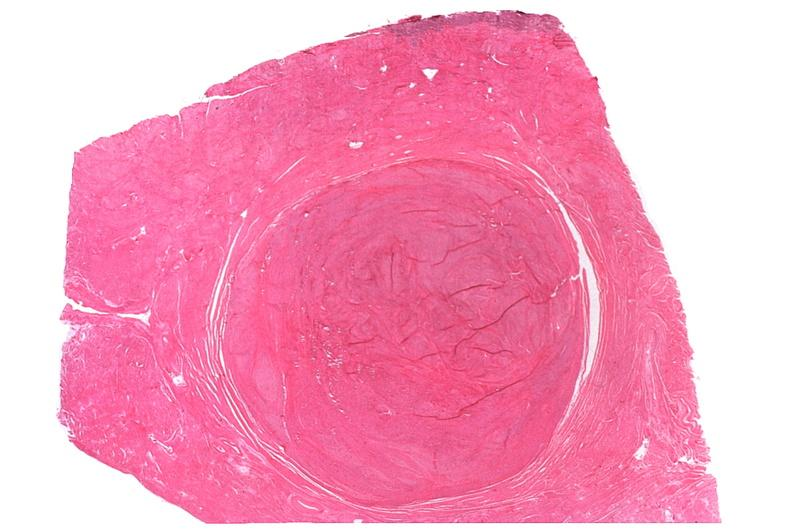what does this image show?
Answer the question using a single word or phrase. Uterus 